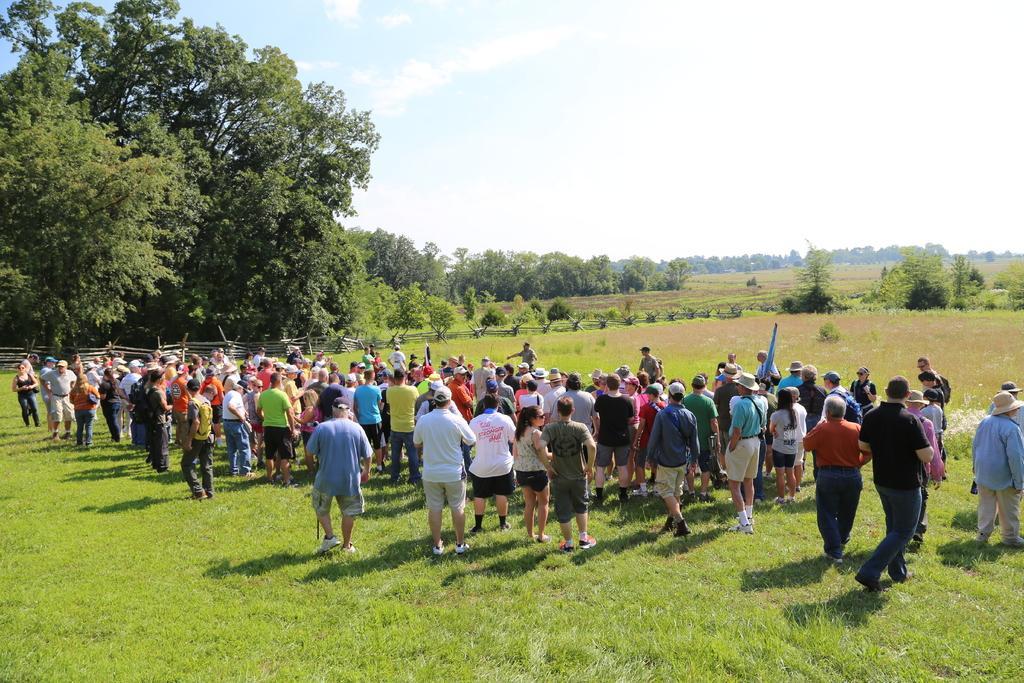Describe this image in one or two sentences. In this image there are many people standing on the grass. Image also consists of many trees. There is also fence. At the top there is sky. 